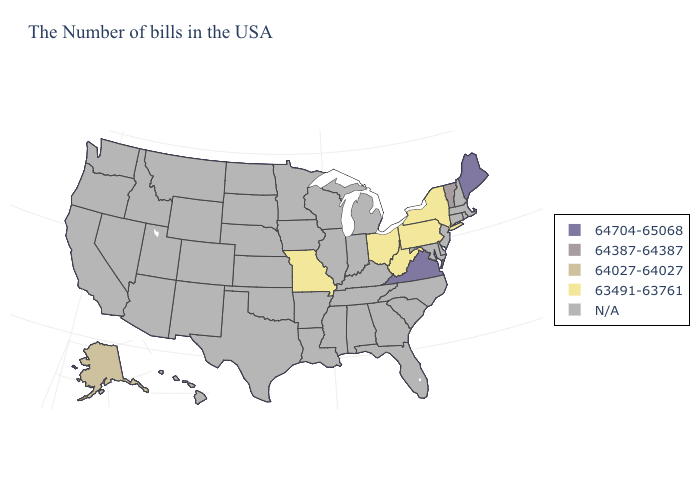Name the states that have a value in the range 63491-63761?
Concise answer only. New York, Pennsylvania, West Virginia, Ohio, Missouri. What is the value of South Carolina?
Quick response, please. N/A. What is the lowest value in the USA?
Be succinct. 63491-63761. Name the states that have a value in the range 64704-65068?
Be succinct. Maine, Virginia. What is the lowest value in the West?
Quick response, please. 64027-64027. What is the value of Montana?
Give a very brief answer. N/A. Name the states that have a value in the range 64027-64027?
Write a very short answer. Alaska. Is the legend a continuous bar?
Short answer required. No. Does the map have missing data?
Short answer required. Yes. Is the legend a continuous bar?
Keep it brief. No. Name the states that have a value in the range 63491-63761?
Write a very short answer. New York, Pennsylvania, West Virginia, Ohio, Missouri. Name the states that have a value in the range 64704-65068?
Write a very short answer. Maine, Virginia. What is the highest value in the South ?
Give a very brief answer. 64704-65068. Does the map have missing data?
Be succinct. Yes. Name the states that have a value in the range 64387-64387?
Give a very brief answer. Vermont. 